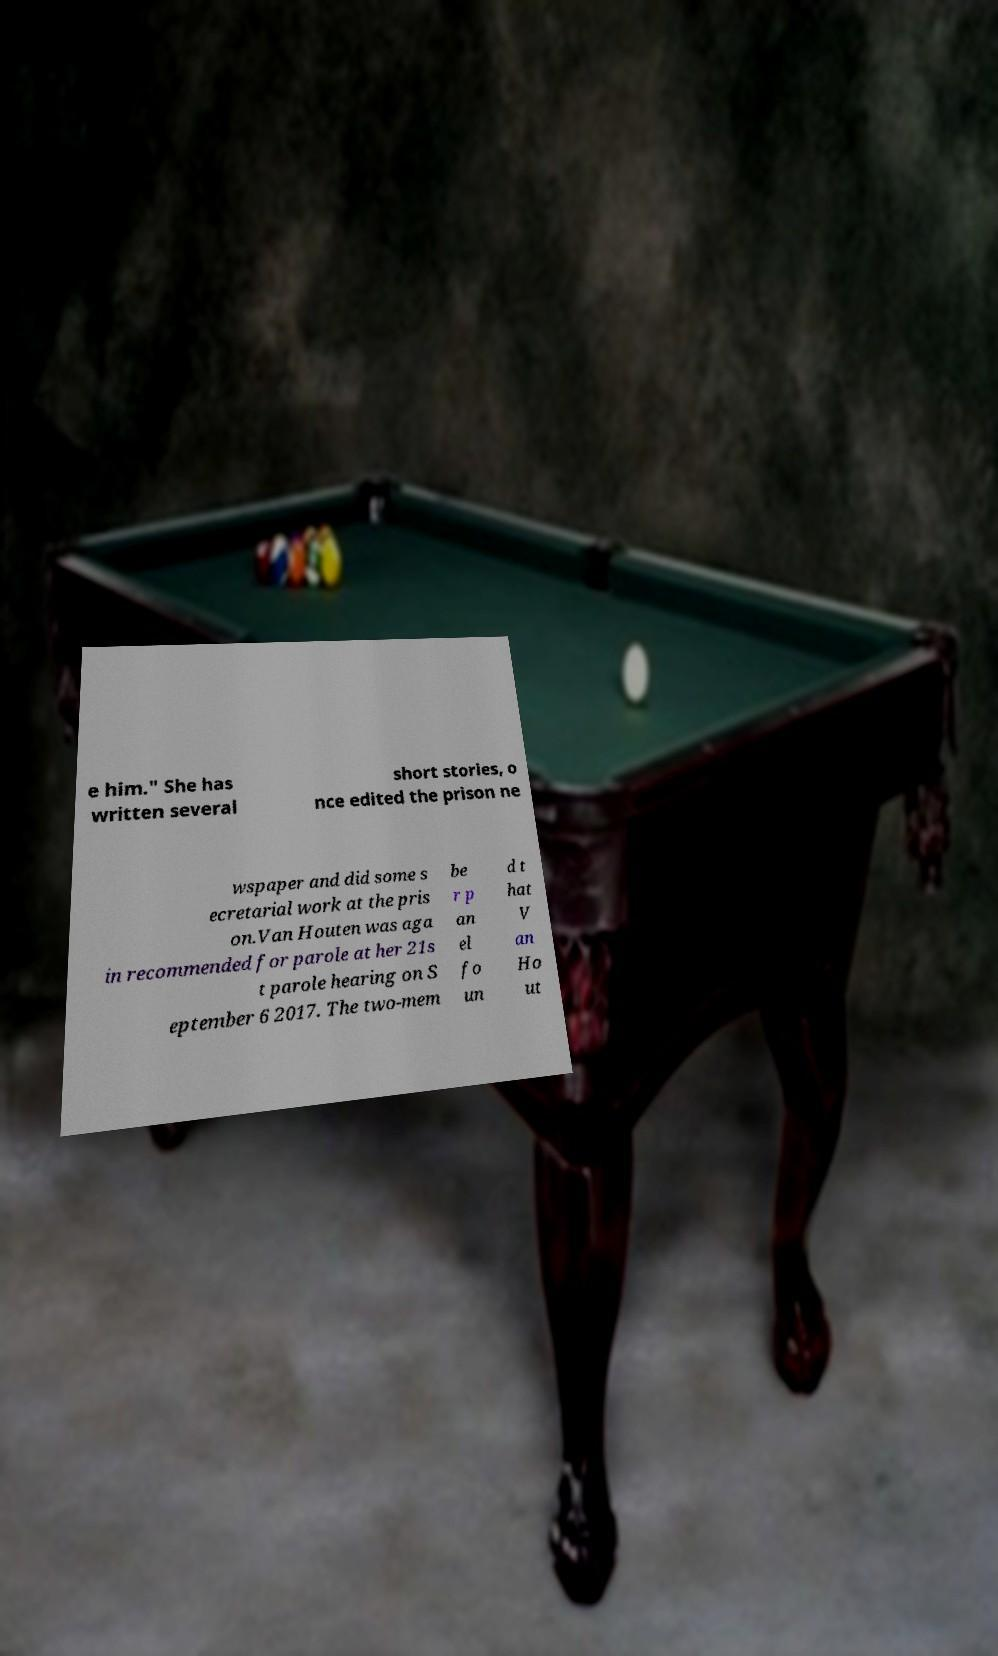Please read and relay the text visible in this image. What does it say? e him." She has written several short stories, o nce edited the prison ne wspaper and did some s ecretarial work at the pris on.Van Houten was aga in recommended for parole at her 21s t parole hearing on S eptember 6 2017. The two-mem be r p an el fo un d t hat V an Ho ut 